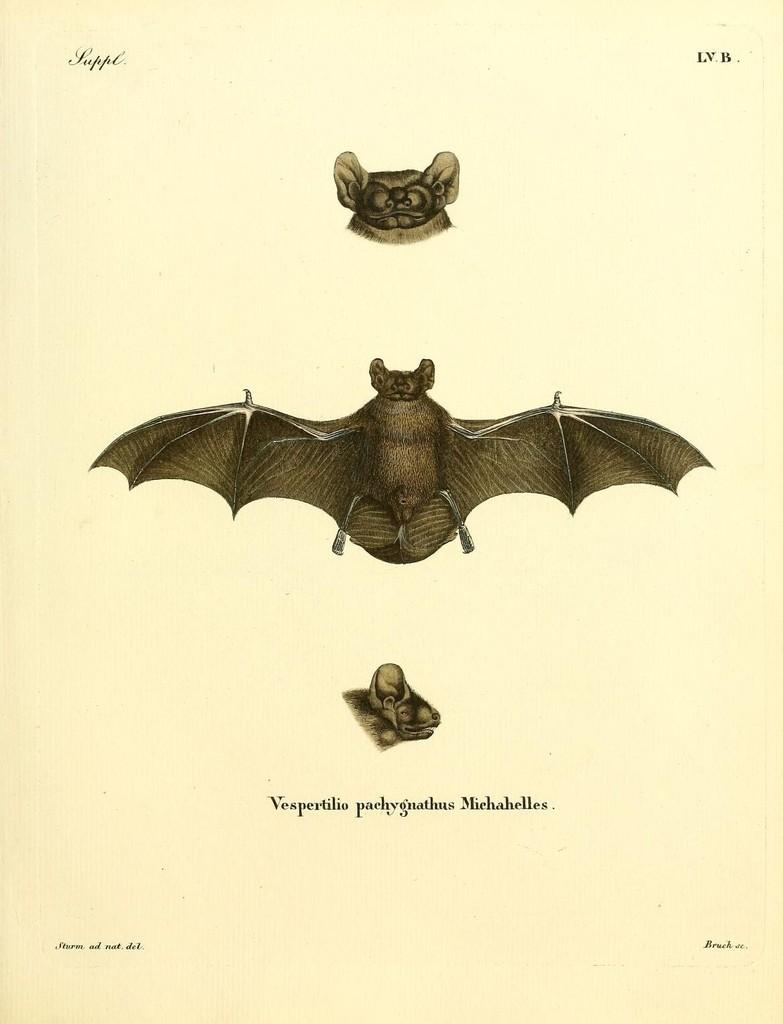What is depicted on the poster in the image? The poster features a butterfly and an insect. Can you describe the main subject of the poster? The main subject of the poster is a butterfly. Are there any other insects or creatures featured on the poster? Yes, there is another insect featured on the poster. What type of rake is being used to collect the butterfly's experience during the week? There is no rake or mention of collecting experiences in the image. The image only features a poster with a butterfly and another insect. 